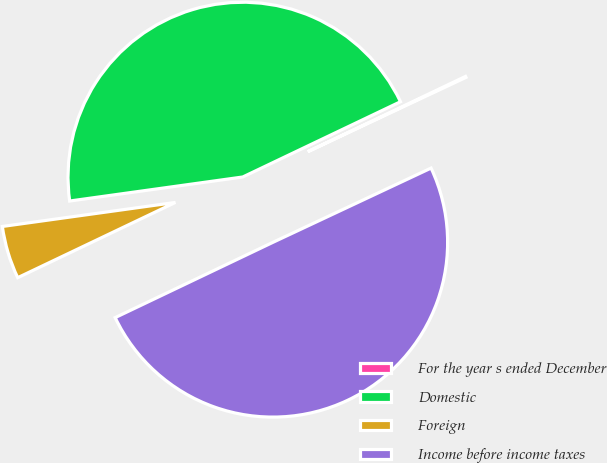Convert chart to OTSL. <chart><loc_0><loc_0><loc_500><loc_500><pie_chart><fcel>For the year s ended December<fcel>Domestic<fcel>Foreign<fcel>Income before income taxes<nl><fcel>0.1%<fcel>45.11%<fcel>4.89%<fcel>49.9%<nl></chart> 